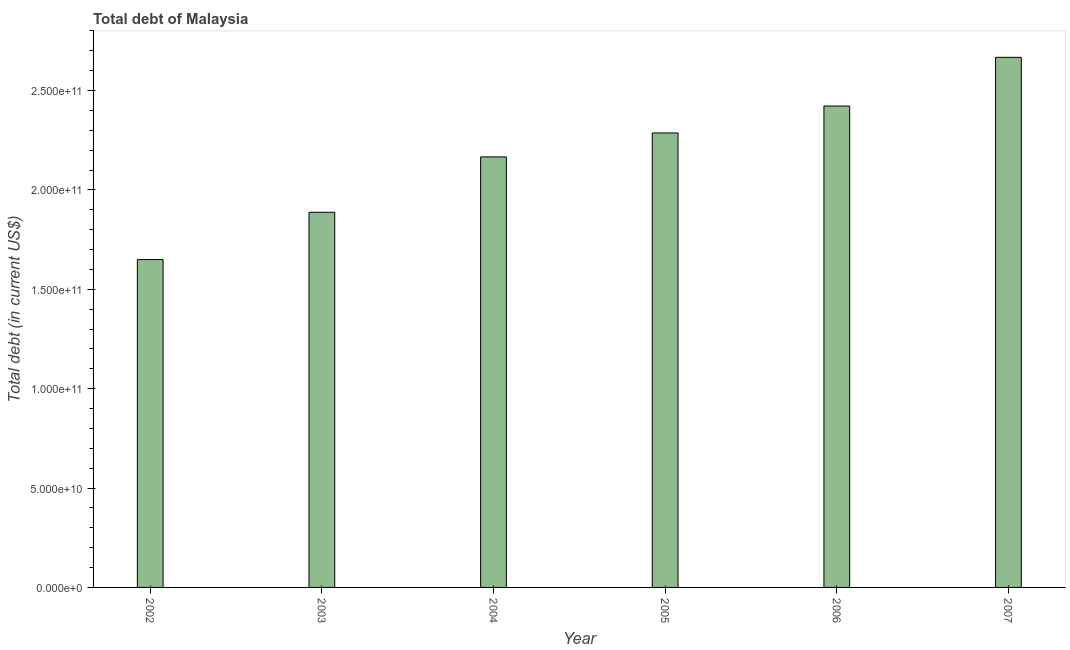Does the graph contain grids?
Offer a very short reply. No. What is the title of the graph?
Keep it short and to the point. Total debt of Malaysia. What is the label or title of the X-axis?
Your answer should be very brief. Year. What is the label or title of the Y-axis?
Your response must be concise. Total debt (in current US$). What is the total debt in 2006?
Your answer should be very brief. 2.42e+11. Across all years, what is the maximum total debt?
Your response must be concise. 2.67e+11. Across all years, what is the minimum total debt?
Your answer should be very brief. 1.65e+11. In which year was the total debt maximum?
Keep it short and to the point. 2007. In which year was the total debt minimum?
Provide a succinct answer. 2002. What is the sum of the total debt?
Ensure brevity in your answer.  1.31e+12. What is the difference between the total debt in 2003 and 2006?
Keep it short and to the point. -5.35e+1. What is the average total debt per year?
Your response must be concise. 2.18e+11. What is the median total debt?
Give a very brief answer. 2.23e+11. In how many years, is the total debt greater than 200000000000 US$?
Your answer should be very brief. 4. What is the ratio of the total debt in 2003 to that in 2006?
Make the answer very short. 0.78. Is the total debt in 2006 less than that in 2007?
Your answer should be very brief. Yes. What is the difference between the highest and the second highest total debt?
Offer a very short reply. 2.45e+1. What is the difference between the highest and the lowest total debt?
Offer a very short reply. 1.02e+11. How many years are there in the graph?
Make the answer very short. 6. What is the difference between two consecutive major ticks on the Y-axis?
Make the answer very short. 5.00e+1. What is the Total debt (in current US$) of 2002?
Make the answer very short. 1.65e+11. What is the Total debt (in current US$) in 2003?
Provide a succinct answer. 1.89e+11. What is the Total debt (in current US$) in 2004?
Your answer should be compact. 2.17e+11. What is the Total debt (in current US$) of 2005?
Offer a terse response. 2.29e+11. What is the Total debt (in current US$) of 2006?
Keep it short and to the point. 2.42e+11. What is the Total debt (in current US$) of 2007?
Your answer should be very brief. 2.67e+11. What is the difference between the Total debt (in current US$) in 2002 and 2003?
Keep it short and to the point. -2.38e+1. What is the difference between the Total debt (in current US$) in 2002 and 2004?
Offer a terse response. -5.17e+1. What is the difference between the Total debt (in current US$) in 2002 and 2005?
Your response must be concise. -6.37e+1. What is the difference between the Total debt (in current US$) in 2002 and 2006?
Offer a very short reply. -7.73e+1. What is the difference between the Total debt (in current US$) in 2002 and 2007?
Your answer should be very brief. -1.02e+11. What is the difference between the Total debt (in current US$) in 2003 and 2004?
Offer a terse response. -2.79e+1. What is the difference between the Total debt (in current US$) in 2003 and 2005?
Give a very brief answer. -3.99e+1. What is the difference between the Total debt (in current US$) in 2003 and 2006?
Your answer should be compact. -5.35e+1. What is the difference between the Total debt (in current US$) in 2003 and 2007?
Offer a very short reply. -7.80e+1. What is the difference between the Total debt (in current US$) in 2004 and 2005?
Your answer should be very brief. -1.20e+1. What is the difference between the Total debt (in current US$) in 2004 and 2006?
Make the answer very short. -2.56e+1. What is the difference between the Total debt (in current US$) in 2004 and 2007?
Offer a very short reply. -5.01e+1. What is the difference between the Total debt (in current US$) in 2005 and 2006?
Keep it short and to the point. -1.36e+1. What is the difference between the Total debt (in current US$) in 2005 and 2007?
Your answer should be compact. -3.81e+1. What is the difference between the Total debt (in current US$) in 2006 and 2007?
Keep it short and to the point. -2.45e+1. What is the ratio of the Total debt (in current US$) in 2002 to that in 2003?
Make the answer very short. 0.87. What is the ratio of the Total debt (in current US$) in 2002 to that in 2004?
Keep it short and to the point. 0.76. What is the ratio of the Total debt (in current US$) in 2002 to that in 2005?
Keep it short and to the point. 0.72. What is the ratio of the Total debt (in current US$) in 2002 to that in 2006?
Keep it short and to the point. 0.68. What is the ratio of the Total debt (in current US$) in 2002 to that in 2007?
Provide a succinct answer. 0.62. What is the ratio of the Total debt (in current US$) in 2003 to that in 2004?
Your answer should be compact. 0.87. What is the ratio of the Total debt (in current US$) in 2003 to that in 2005?
Your response must be concise. 0.82. What is the ratio of the Total debt (in current US$) in 2003 to that in 2006?
Your answer should be compact. 0.78. What is the ratio of the Total debt (in current US$) in 2003 to that in 2007?
Provide a short and direct response. 0.71. What is the ratio of the Total debt (in current US$) in 2004 to that in 2005?
Ensure brevity in your answer.  0.95. What is the ratio of the Total debt (in current US$) in 2004 to that in 2006?
Your response must be concise. 0.89. What is the ratio of the Total debt (in current US$) in 2004 to that in 2007?
Your response must be concise. 0.81. What is the ratio of the Total debt (in current US$) in 2005 to that in 2006?
Your response must be concise. 0.94. What is the ratio of the Total debt (in current US$) in 2005 to that in 2007?
Provide a succinct answer. 0.86. What is the ratio of the Total debt (in current US$) in 2006 to that in 2007?
Your answer should be very brief. 0.91. 